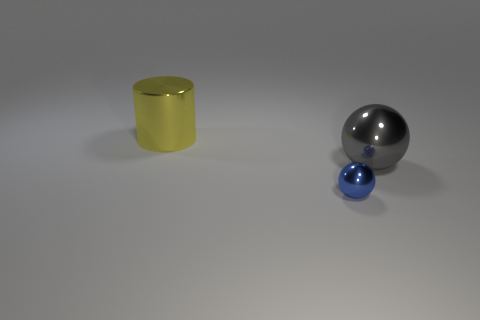Is there any other thing that is the same size as the blue metal object?
Provide a succinct answer. No. What shape is the thing to the left of the object that is in front of the large ball?
Offer a very short reply. Cylinder. How many objects are either tiny metal balls or things in front of the large shiny cylinder?
Keep it short and to the point. 2. There is a shiny ball in front of the metal thing that is on the right side of the metal thing in front of the gray ball; what color is it?
Give a very brief answer. Blue. There is a big gray thing that is the same shape as the blue metal thing; what is its material?
Make the answer very short. Metal. What color is the tiny ball?
Offer a terse response. Blue. Does the big ball have the same color as the large cylinder?
Your response must be concise. No. What number of metal things are either big cylinders or gray cubes?
Offer a very short reply. 1. There is a large shiny thing in front of the metal thing that is behind the big gray metallic object; is there a large yellow cylinder in front of it?
Keep it short and to the point. No. The blue ball that is made of the same material as the big yellow object is what size?
Ensure brevity in your answer.  Small. 